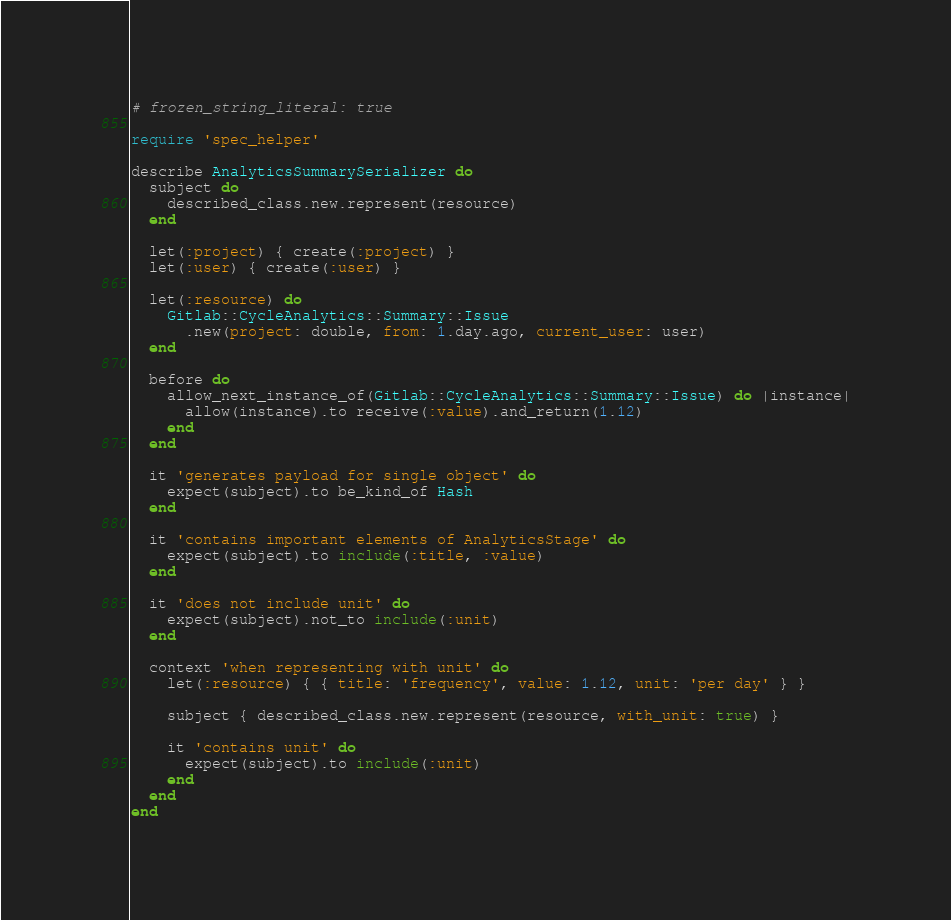Convert code to text. <code><loc_0><loc_0><loc_500><loc_500><_Ruby_># frozen_string_literal: true

require 'spec_helper'

describe AnalyticsSummarySerializer do
  subject do
    described_class.new.represent(resource)
  end

  let(:project) { create(:project) }
  let(:user) { create(:user) }

  let(:resource) do
    Gitlab::CycleAnalytics::Summary::Issue
      .new(project: double, from: 1.day.ago, current_user: user)
  end

  before do
    allow_next_instance_of(Gitlab::CycleAnalytics::Summary::Issue) do |instance|
      allow(instance).to receive(:value).and_return(1.12)
    end
  end

  it 'generates payload for single object' do
    expect(subject).to be_kind_of Hash
  end

  it 'contains important elements of AnalyticsStage' do
    expect(subject).to include(:title, :value)
  end

  it 'does not include unit' do
    expect(subject).not_to include(:unit)
  end

  context 'when representing with unit' do
    let(:resource) { { title: 'frequency', value: 1.12, unit: 'per day' } }

    subject { described_class.new.represent(resource, with_unit: true) }

    it 'contains unit' do
      expect(subject).to include(:unit)
    end
  end
end
</code> 